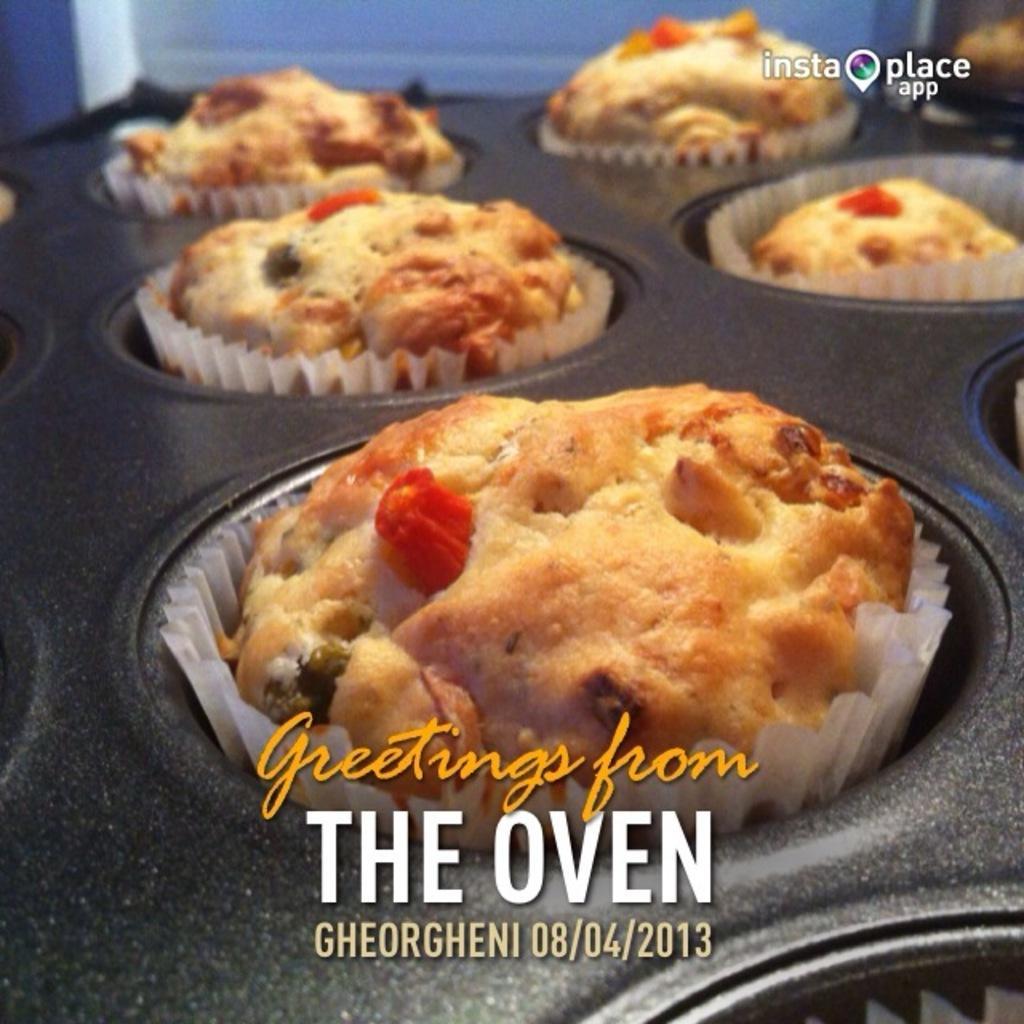How would you summarize this image in a sentence or two? In this image I can see few cupcakes in the cupcake-tray and something is written on it. 